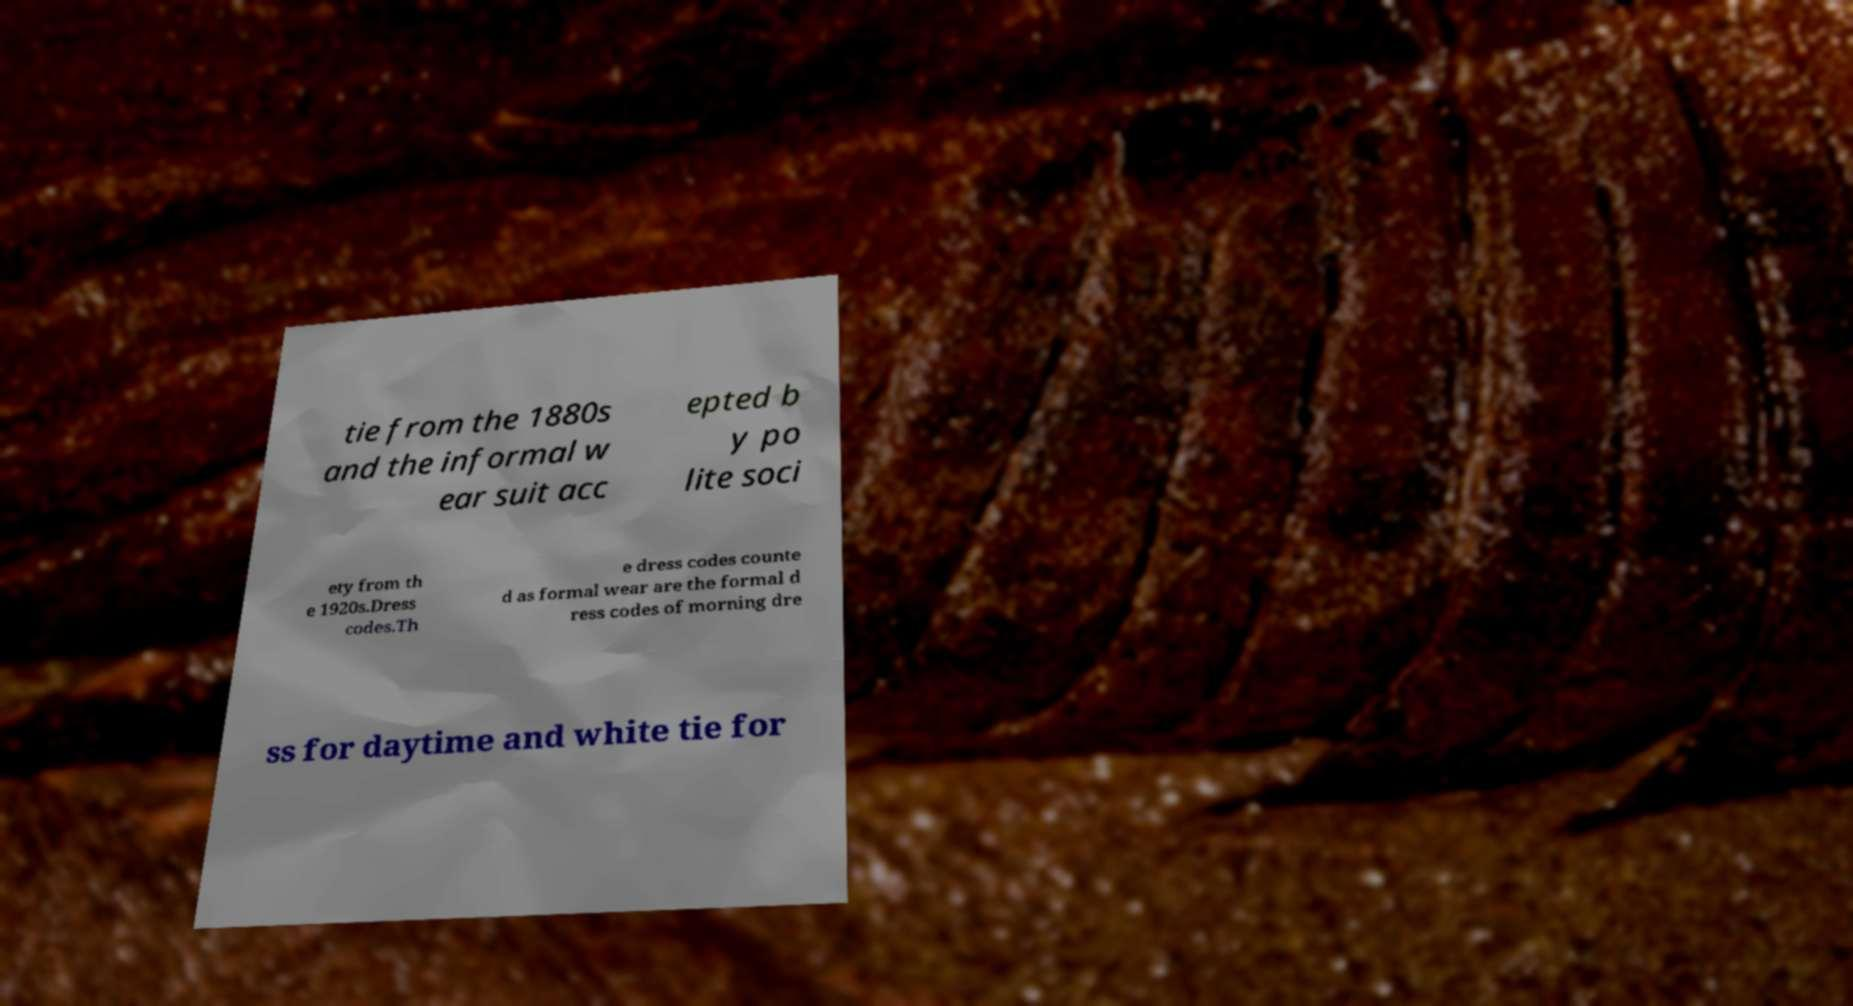I need the written content from this picture converted into text. Can you do that? tie from the 1880s and the informal w ear suit acc epted b y po lite soci ety from th e 1920s.Dress codes.Th e dress codes counte d as formal wear are the formal d ress codes of morning dre ss for daytime and white tie for 